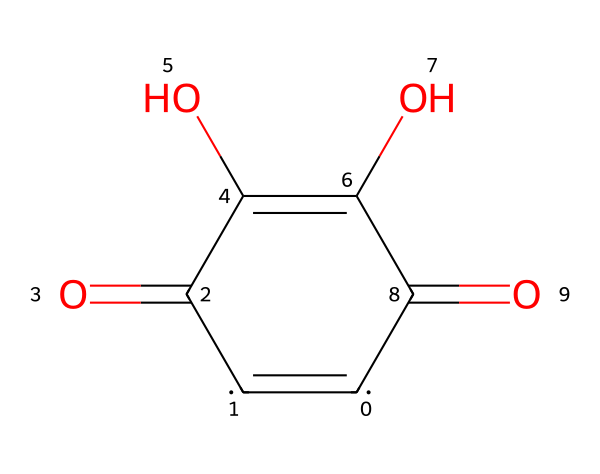What is the total number of carbon atoms in this structure? Analyzing the SMILES representation, we count the number of carbon symbols '[C]'. The structure has four carbon atoms represented in the cyclic structure and one carbon from the carbonyl group, totaling five.
Answer: 5 How many double bonds are present in the chemical structure? By examining the SMILES, we identify the '=' signs that represent double bonds. There are four double bonds formed between carbons and the carbonyl oxygen groups.
Answer: 4 What functional groups are present in this chemical? In the SMILES representation, we note the presence of carbonyl groups (C=O) and hydroxyl groups (–OH). The carbonyl groups are indicated by '=O' and the hydroxyl groups by (O) indicating attached to carbon.
Answer: carbonyl and hydroxyl Does this chemical contain any heteroatoms? Heteroatoms are defined as atoms other than carbon and hydrogen. Reviewing the SMILES, we find the presence of oxygen atoms. Specifically, there are four oxygen atoms which qualify as heteroatoms.
Answer: yes What type of bonding characterizes the carbon-oxygen bonds in this compound? Looking at the bonds involving carbon and oxygen in the SMILES structure, we note these bonds can exhibit both double bond character (in the carbonyls) and single bond character (in the alcohols). Therefore, both types of bonding are involved.
Answer: both Is this chemical likely to be a good lubricant based on its structure? The presence of hydroxyl groups can enhance the interaction with polar surfaces, potentially improving lubrication properties. However, the overall aromaticity and rigidity of the structure may hinder fluidity compared to more typical lubricants.
Answer: possibly 